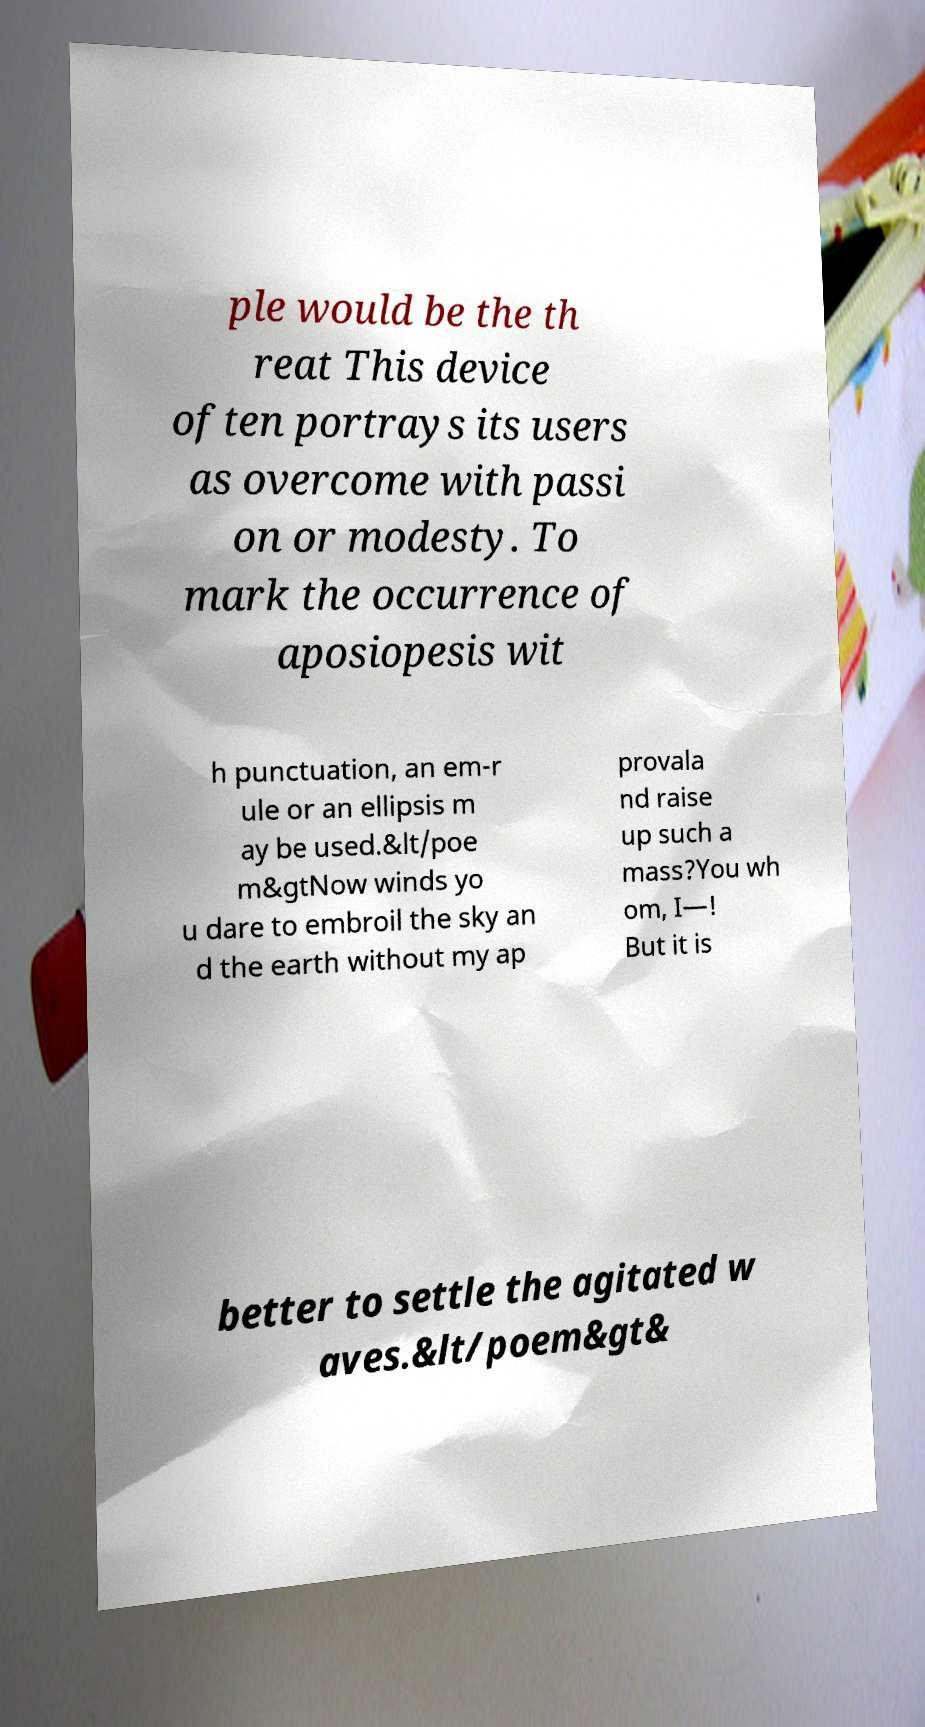Please read and relay the text visible in this image. What does it say? ple would be the th reat This device often portrays its users as overcome with passi on or modesty. To mark the occurrence of aposiopesis wit h punctuation, an em-r ule or an ellipsis m ay be used.&lt/poe m&gtNow winds yo u dare to embroil the sky an d the earth without my ap provala nd raise up such a mass?You wh om, I—! But it is better to settle the agitated w aves.&lt/poem&gt& 